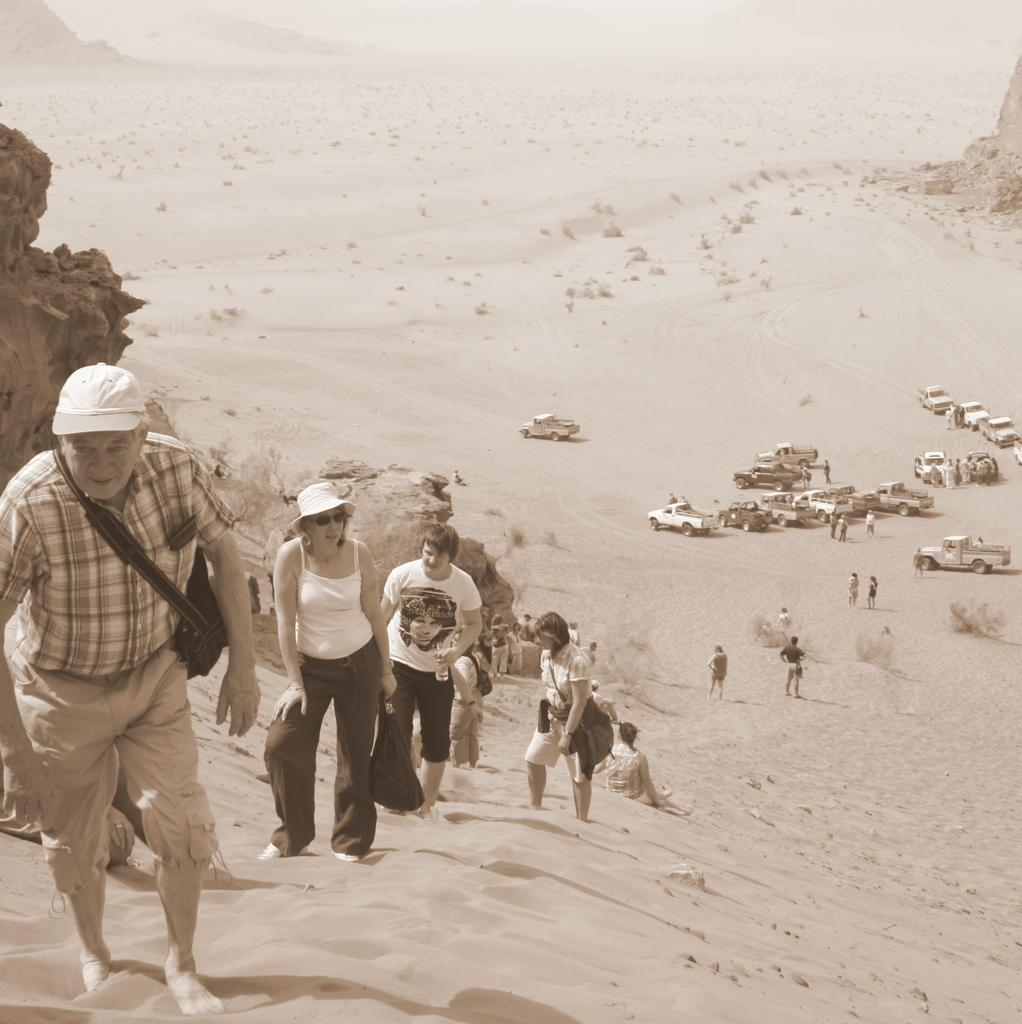What type of environment is shown in the image? The image depicts a desert. How many people are present in the image? There are many people in the image. What else can be seen in the image besides people? There are many vehicles in the image. What are some people doing in the image? Some people are carrying objects in the image. What type of soup is being served in the image? There is no soup present in the image; it depicts a desert environment with people and vehicles. 